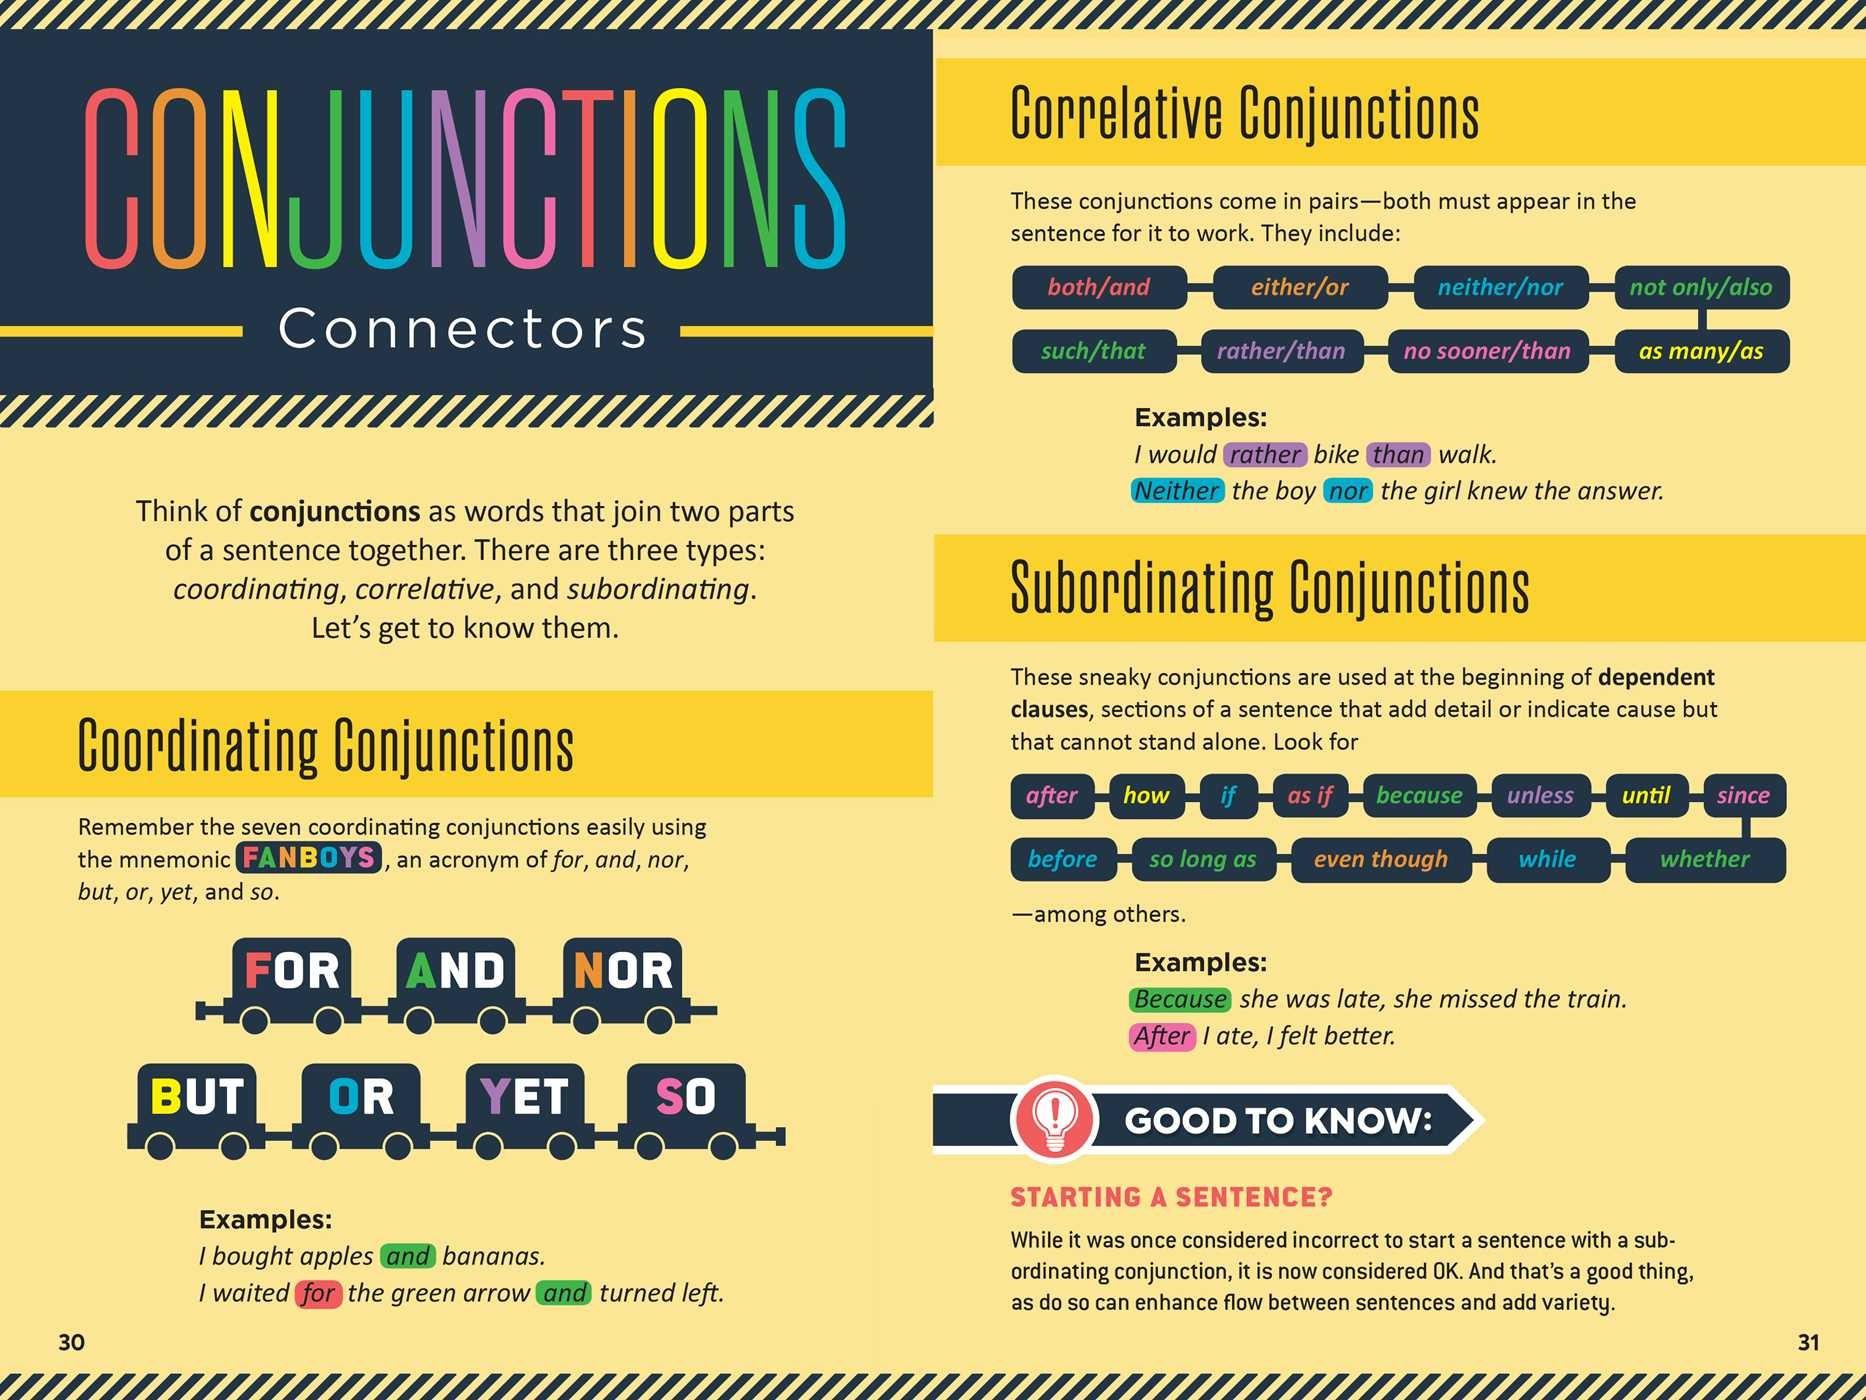Indicate a few pertinent items in this graphic. Both" is a pair of correlative conjunction that is used to link two ideas or concepts. The two ideas or concepts that are linked by "both" must be present in the same context and are typically used to indicate a high degree of similarity or co-occurrence between them. For example, "He is smart and hardworking, and both traits are essential for success. After" and "how" are subordinating conjunctions. The fourth coordinating conjunction listed in the infographic is "but. Conjunctions are also known as connectors. Even though" is an example of a subordinating conjunction. 